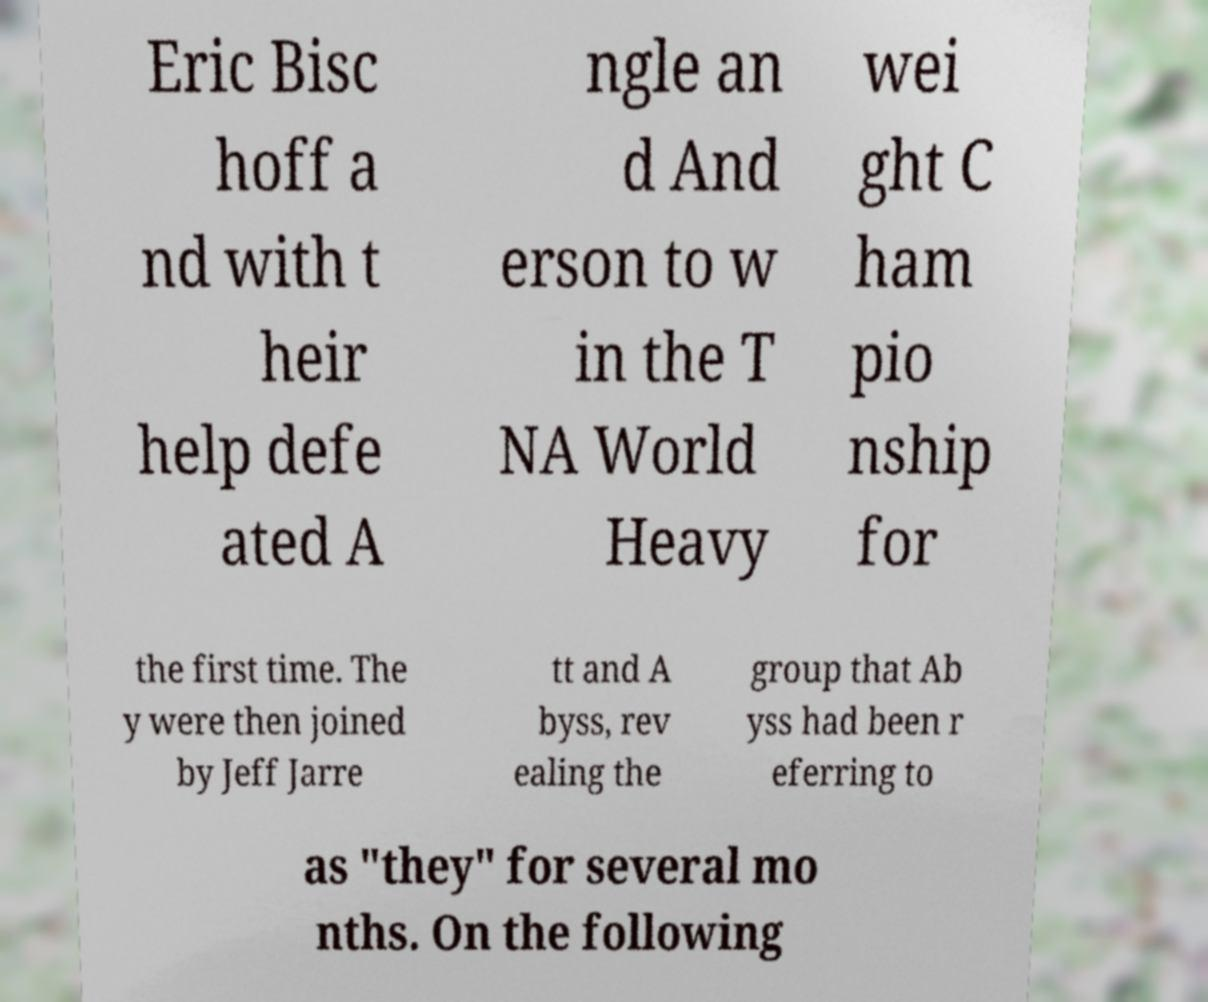Can you accurately transcribe the text from the provided image for me? Eric Bisc hoff a nd with t heir help defe ated A ngle an d And erson to w in the T NA World Heavy wei ght C ham pio nship for the first time. The y were then joined by Jeff Jarre tt and A byss, rev ealing the group that Ab yss had been r eferring to as "they" for several mo nths. On the following 